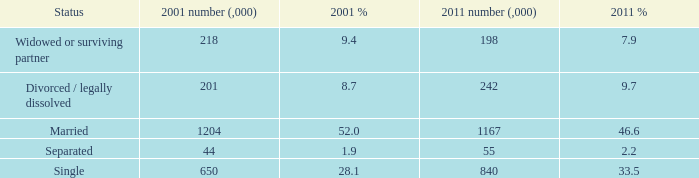What is the 2011 number (,000) when the status is separated? 55.0. 